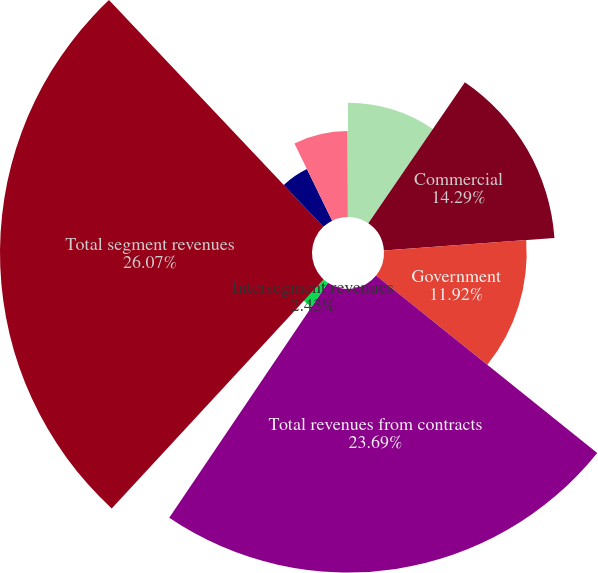Convert chart to OTSL. <chart><loc_0><loc_0><loc_500><loc_500><pie_chart><fcel>Years ended December 31<fcel>Commercial<fcel>Government<fcel>Total revenues from contracts<fcel>Intersegment revenues<fcel>Total segment revenues<fcel>Revenue recognized at a point<fcel>Revenue recognized on<fcel>Revenue from the US government<nl><fcel>9.55%<fcel>14.29%<fcel>11.92%<fcel>23.69%<fcel>2.43%<fcel>26.07%<fcel>4.81%<fcel>7.18%<fcel>0.06%<nl></chart> 